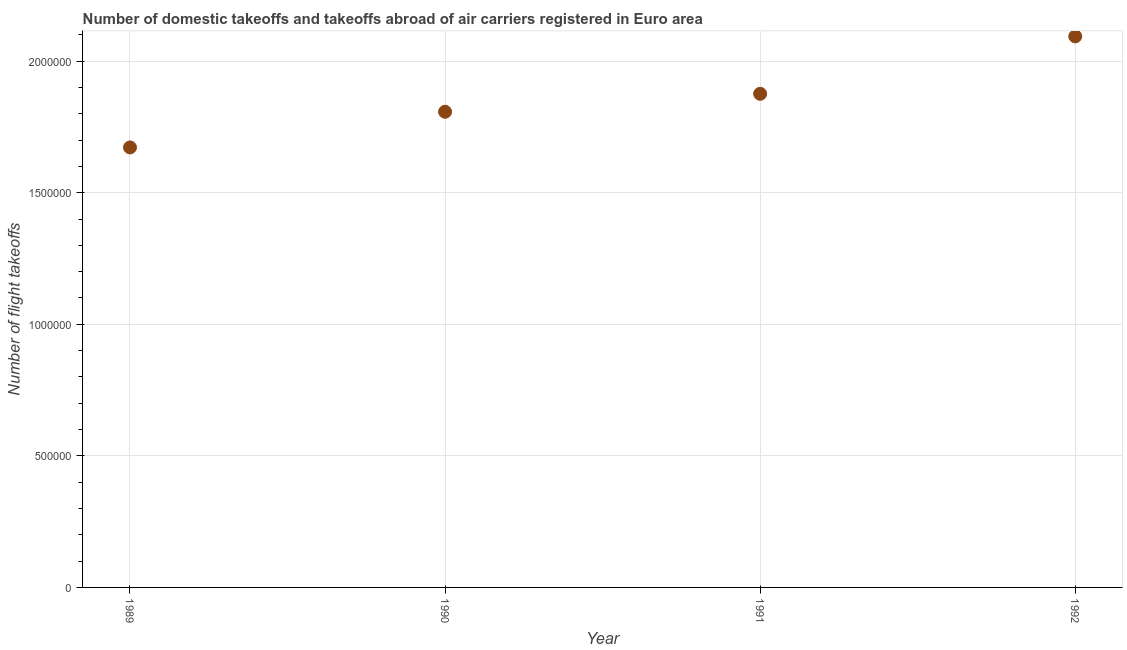What is the number of flight takeoffs in 1990?
Your response must be concise. 1.81e+06. Across all years, what is the maximum number of flight takeoffs?
Your answer should be very brief. 2.09e+06. Across all years, what is the minimum number of flight takeoffs?
Give a very brief answer. 1.67e+06. In which year was the number of flight takeoffs maximum?
Give a very brief answer. 1992. In which year was the number of flight takeoffs minimum?
Give a very brief answer. 1989. What is the sum of the number of flight takeoffs?
Your answer should be compact. 7.45e+06. What is the difference between the number of flight takeoffs in 1990 and 1992?
Make the answer very short. -2.86e+05. What is the average number of flight takeoffs per year?
Provide a succinct answer. 1.86e+06. What is the median number of flight takeoffs?
Your response must be concise. 1.84e+06. In how many years, is the number of flight takeoffs greater than 1100000 ?
Ensure brevity in your answer.  4. What is the ratio of the number of flight takeoffs in 1990 to that in 1991?
Provide a succinct answer. 0.96. Is the number of flight takeoffs in 1989 less than that in 1990?
Provide a succinct answer. Yes. Is the difference between the number of flight takeoffs in 1989 and 1992 greater than the difference between any two years?
Offer a very short reply. Yes. What is the difference between the highest and the second highest number of flight takeoffs?
Provide a succinct answer. 2.18e+05. Is the sum of the number of flight takeoffs in 1990 and 1991 greater than the maximum number of flight takeoffs across all years?
Your answer should be very brief. Yes. What is the difference between the highest and the lowest number of flight takeoffs?
Your answer should be very brief. 4.22e+05. Does the number of flight takeoffs monotonically increase over the years?
Provide a succinct answer. Yes. How many years are there in the graph?
Offer a very short reply. 4. What is the difference between two consecutive major ticks on the Y-axis?
Offer a very short reply. 5.00e+05. Are the values on the major ticks of Y-axis written in scientific E-notation?
Your answer should be compact. No. Does the graph contain any zero values?
Your answer should be compact. No. Does the graph contain grids?
Your answer should be very brief. Yes. What is the title of the graph?
Keep it short and to the point. Number of domestic takeoffs and takeoffs abroad of air carriers registered in Euro area. What is the label or title of the X-axis?
Keep it short and to the point. Year. What is the label or title of the Y-axis?
Offer a very short reply. Number of flight takeoffs. What is the Number of flight takeoffs in 1989?
Offer a terse response. 1.67e+06. What is the Number of flight takeoffs in 1990?
Keep it short and to the point. 1.81e+06. What is the Number of flight takeoffs in 1991?
Your answer should be very brief. 1.88e+06. What is the Number of flight takeoffs in 1992?
Give a very brief answer. 2.09e+06. What is the difference between the Number of flight takeoffs in 1989 and 1990?
Offer a very short reply. -1.36e+05. What is the difference between the Number of flight takeoffs in 1989 and 1991?
Ensure brevity in your answer.  -2.04e+05. What is the difference between the Number of flight takeoffs in 1989 and 1992?
Give a very brief answer. -4.22e+05. What is the difference between the Number of flight takeoffs in 1990 and 1991?
Ensure brevity in your answer.  -6.83e+04. What is the difference between the Number of flight takeoffs in 1990 and 1992?
Give a very brief answer. -2.86e+05. What is the difference between the Number of flight takeoffs in 1991 and 1992?
Provide a short and direct response. -2.18e+05. What is the ratio of the Number of flight takeoffs in 1989 to that in 1990?
Your response must be concise. 0.93. What is the ratio of the Number of flight takeoffs in 1989 to that in 1991?
Your answer should be very brief. 0.89. What is the ratio of the Number of flight takeoffs in 1989 to that in 1992?
Your answer should be very brief. 0.8. What is the ratio of the Number of flight takeoffs in 1990 to that in 1992?
Give a very brief answer. 0.86. What is the ratio of the Number of flight takeoffs in 1991 to that in 1992?
Offer a terse response. 0.9. 